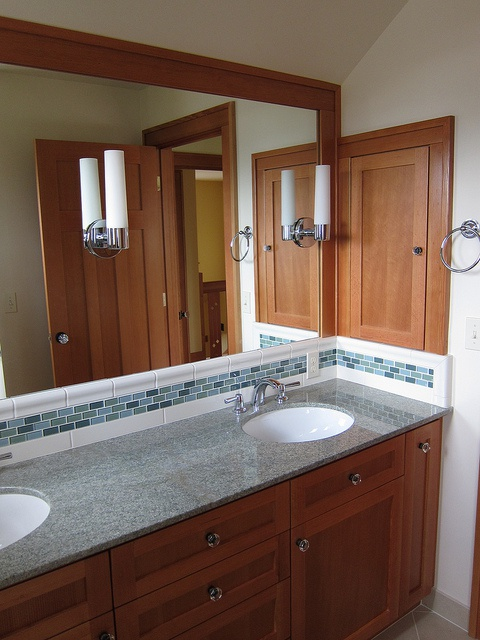Describe the objects in this image and their specific colors. I can see sink in gray, lavender, darkgray, and lightgray tones and sink in gray, lightgray, and darkgray tones in this image. 